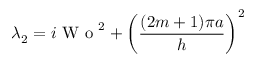Convert formula to latex. <formula><loc_0><loc_0><loc_500><loc_500>\lambda _ { 2 } = i W o ^ { 2 } + \left ( \frac { ( 2 m + 1 ) \pi a } { h } \right ) ^ { 2 }</formula> 